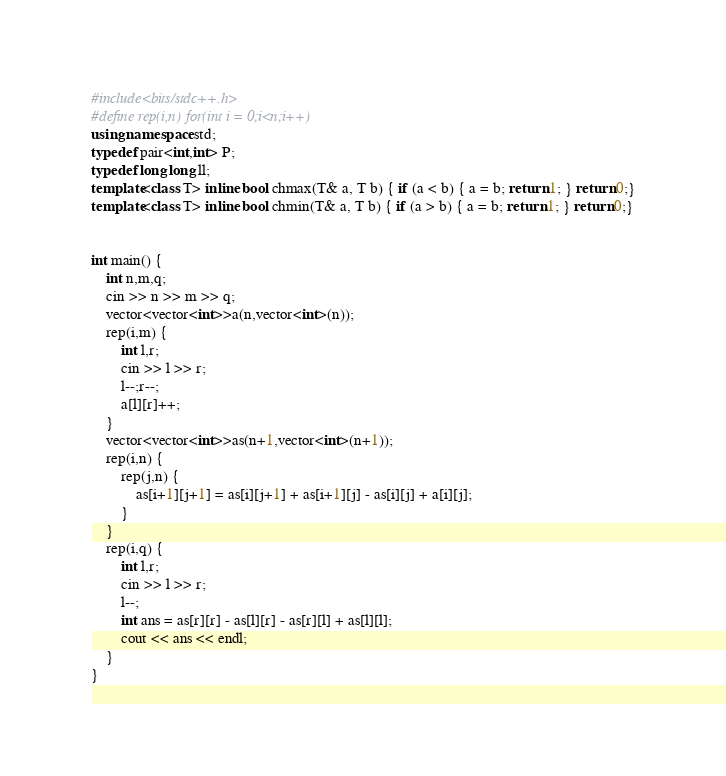Convert code to text. <code><loc_0><loc_0><loc_500><loc_500><_C++_>#include<bits/stdc++.h>
#define rep(i,n) for(int i = 0;i<n;i++)
using namespace std;
typedef pair<int,int> P;
typedef long long ll;
template<class T> inline bool chmax(T& a, T b) { if (a < b) { a = b; return 1; } return 0;}
template<class T> inline bool chmin(T& a, T b) { if (a > b) { a = b; return 1; } return 0;}


int main() {
    int n,m,q;
    cin >> n >> m >> q;
    vector<vector<int>>a(n,vector<int>(n));
    rep(i,m) {
        int l,r;
        cin >> l >> r;
        l--;r--;
        a[l][r]++;
    }
    vector<vector<int>>as(n+1,vector<int>(n+1));
    rep(i,n) {
        rep(j,n) {
            as[i+1][j+1] = as[i][j+1] + as[i+1][j] - as[i][j] + a[i][j];
        }
    }
    rep(i,q) {
        int l,r;
        cin >> l >> r;
        l--;
        int ans = as[r][r] - as[l][r] - as[r][l] + as[l][l];
        cout << ans << endl;
    }
}</code> 